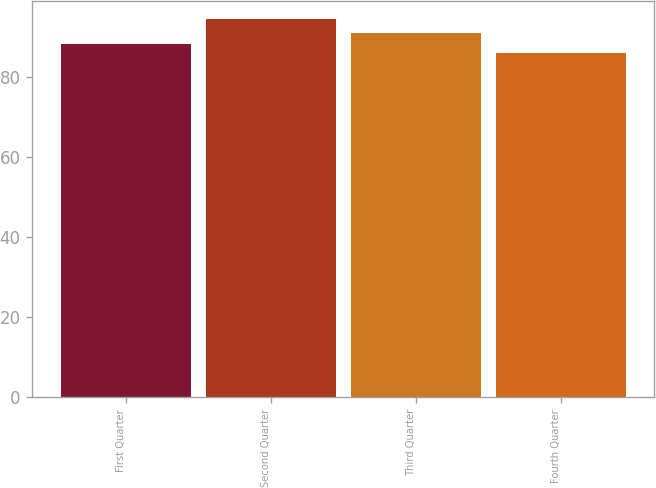Convert chart to OTSL. <chart><loc_0><loc_0><loc_500><loc_500><bar_chart><fcel>First Quarter<fcel>Second Quarter<fcel>Third Quarter<fcel>Fourth Quarter<nl><fcel>88.18<fcel>94.38<fcel>91<fcel>85.91<nl></chart> 